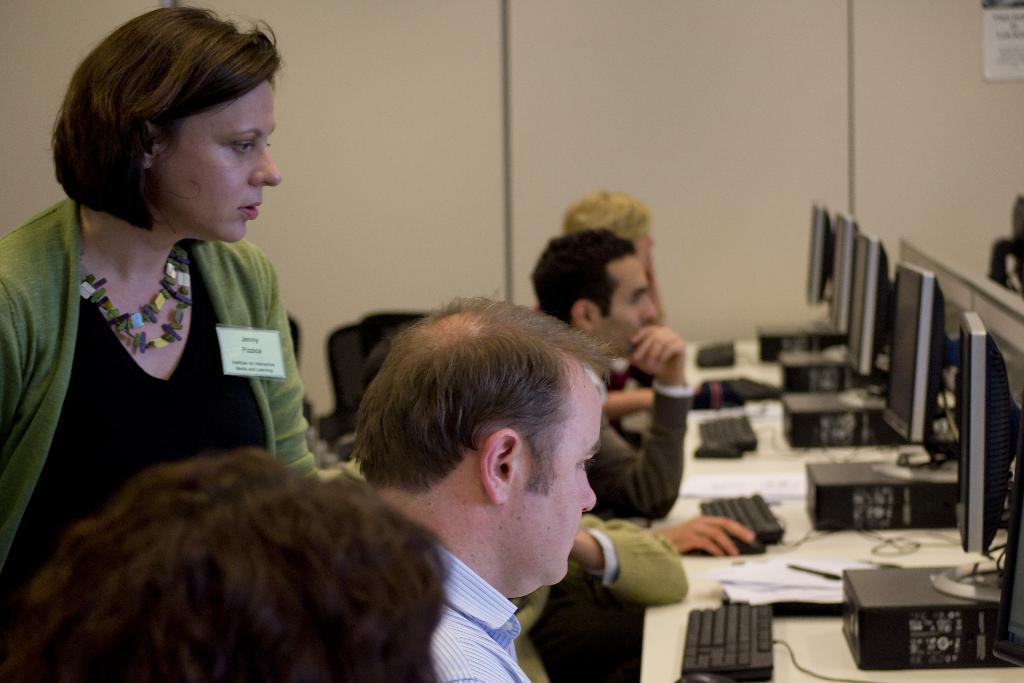Describe this image in one or two sentences. It is a computer lab there are many computers on the desk, some people are sitting in front of it and working, a women wearing green jacket is helping the person who is working with the first computer, in the background there is a cream color wall. 